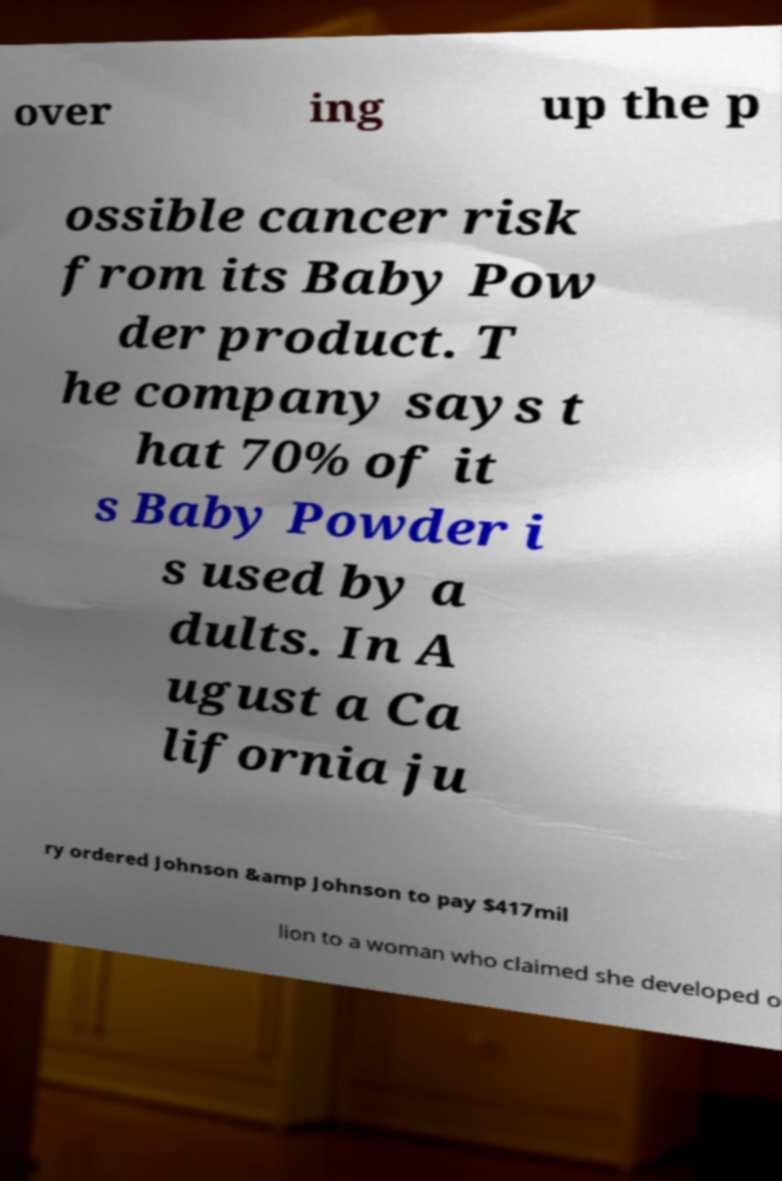Could you extract and type out the text from this image? over ing up the p ossible cancer risk from its Baby Pow der product. T he company says t hat 70% of it s Baby Powder i s used by a dults. In A ugust a Ca lifornia ju ry ordered Johnson &amp Johnson to pay $417mil lion to a woman who claimed she developed o 